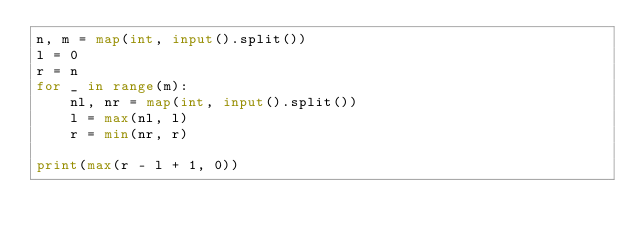<code> <loc_0><loc_0><loc_500><loc_500><_Python_>n, m = map(int, input().split())
l = 0
r = n
for _ in range(m):
    nl, nr = map(int, input().split())
    l = max(nl, l)
    r = min(nr, r)
 
print(max(r - l + 1, 0))</code> 